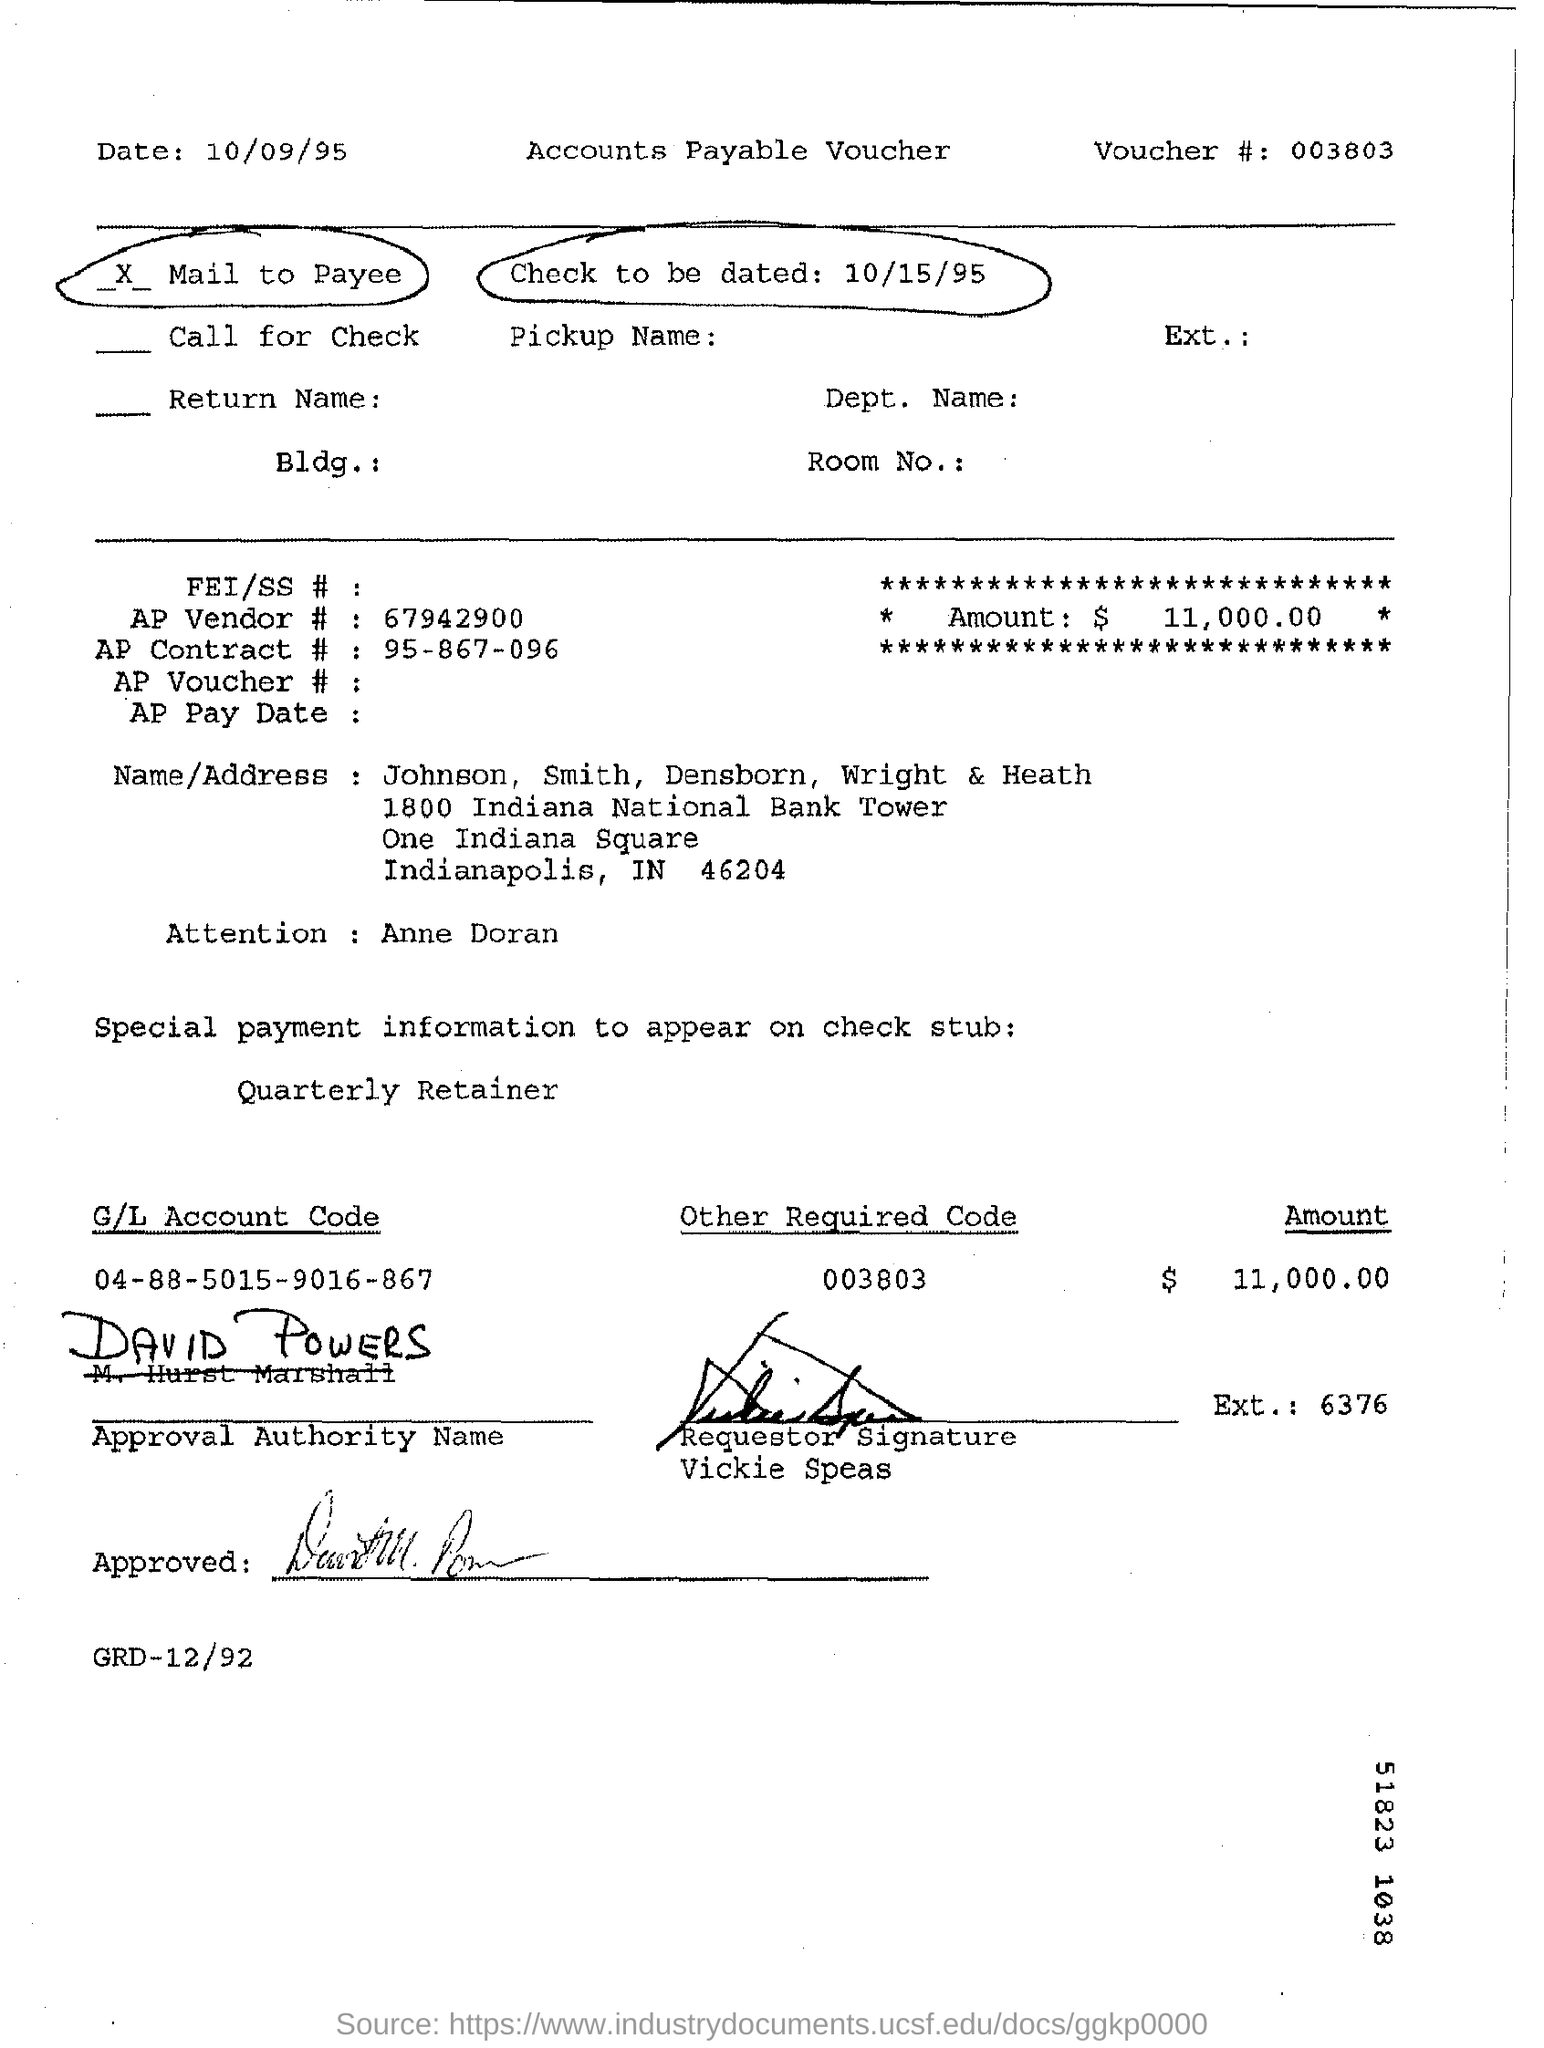Mention a couple of crucial points in this snapshot. The requestor is Vickie Speas. The check indicates that $11,000.00 is the amount mentioned on the check. The AP contract number is 95-867-096... The voucher number is 003803. The check is to be dated on October 15, 1995. 